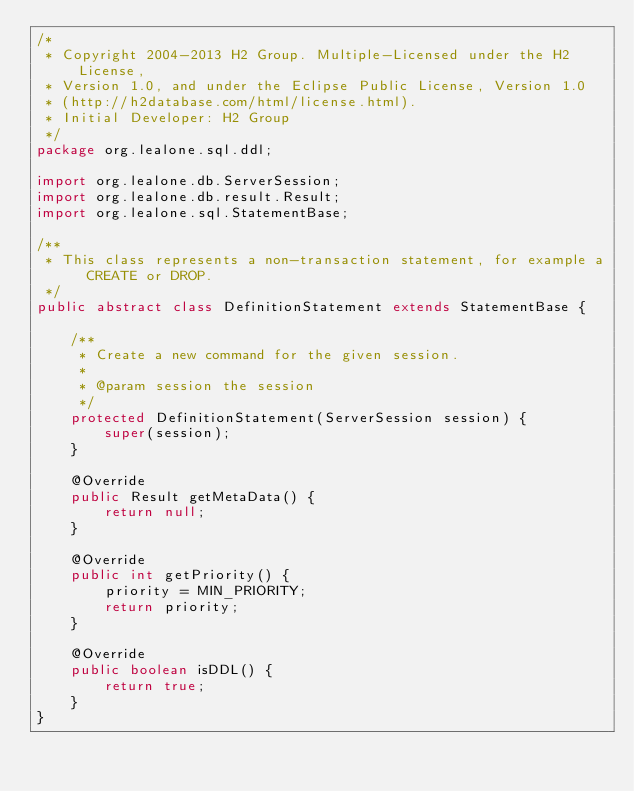Convert code to text. <code><loc_0><loc_0><loc_500><loc_500><_Java_>/*
 * Copyright 2004-2013 H2 Group. Multiple-Licensed under the H2 License,
 * Version 1.0, and under the Eclipse Public License, Version 1.0
 * (http://h2database.com/html/license.html).
 * Initial Developer: H2 Group
 */
package org.lealone.sql.ddl;

import org.lealone.db.ServerSession;
import org.lealone.db.result.Result;
import org.lealone.sql.StatementBase;

/**
 * This class represents a non-transaction statement, for example a CREATE or DROP.
 */
public abstract class DefinitionStatement extends StatementBase {

    /**
     * Create a new command for the given session.
     *
     * @param session the session
     */
    protected DefinitionStatement(ServerSession session) {
        super(session);
    }

    @Override
    public Result getMetaData() {
        return null;
    }

    @Override
    public int getPriority() {
        priority = MIN_PRIORITY;
        return priority;
    }

    @Override
    public boolean isDDL() {
        return true;
    }
}
</code> 